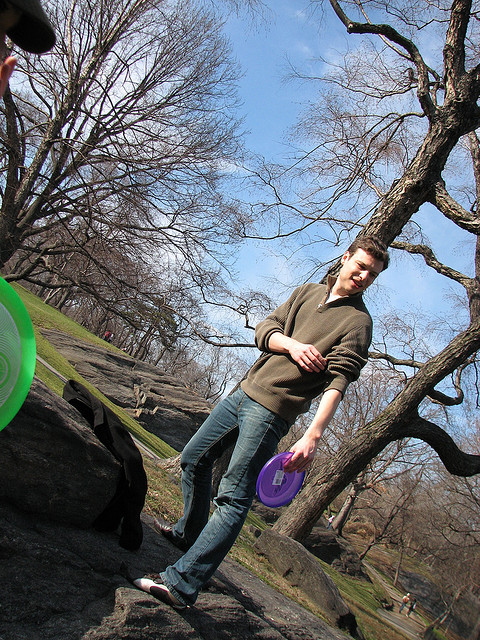<image>Was this picture taken on an angle? I don't know if the picture was taken on an angle. Was this picture taken on an angle? I don't know if this picture was taken on an angle. It is possible that it was taken on an angle based on the answers provided. 